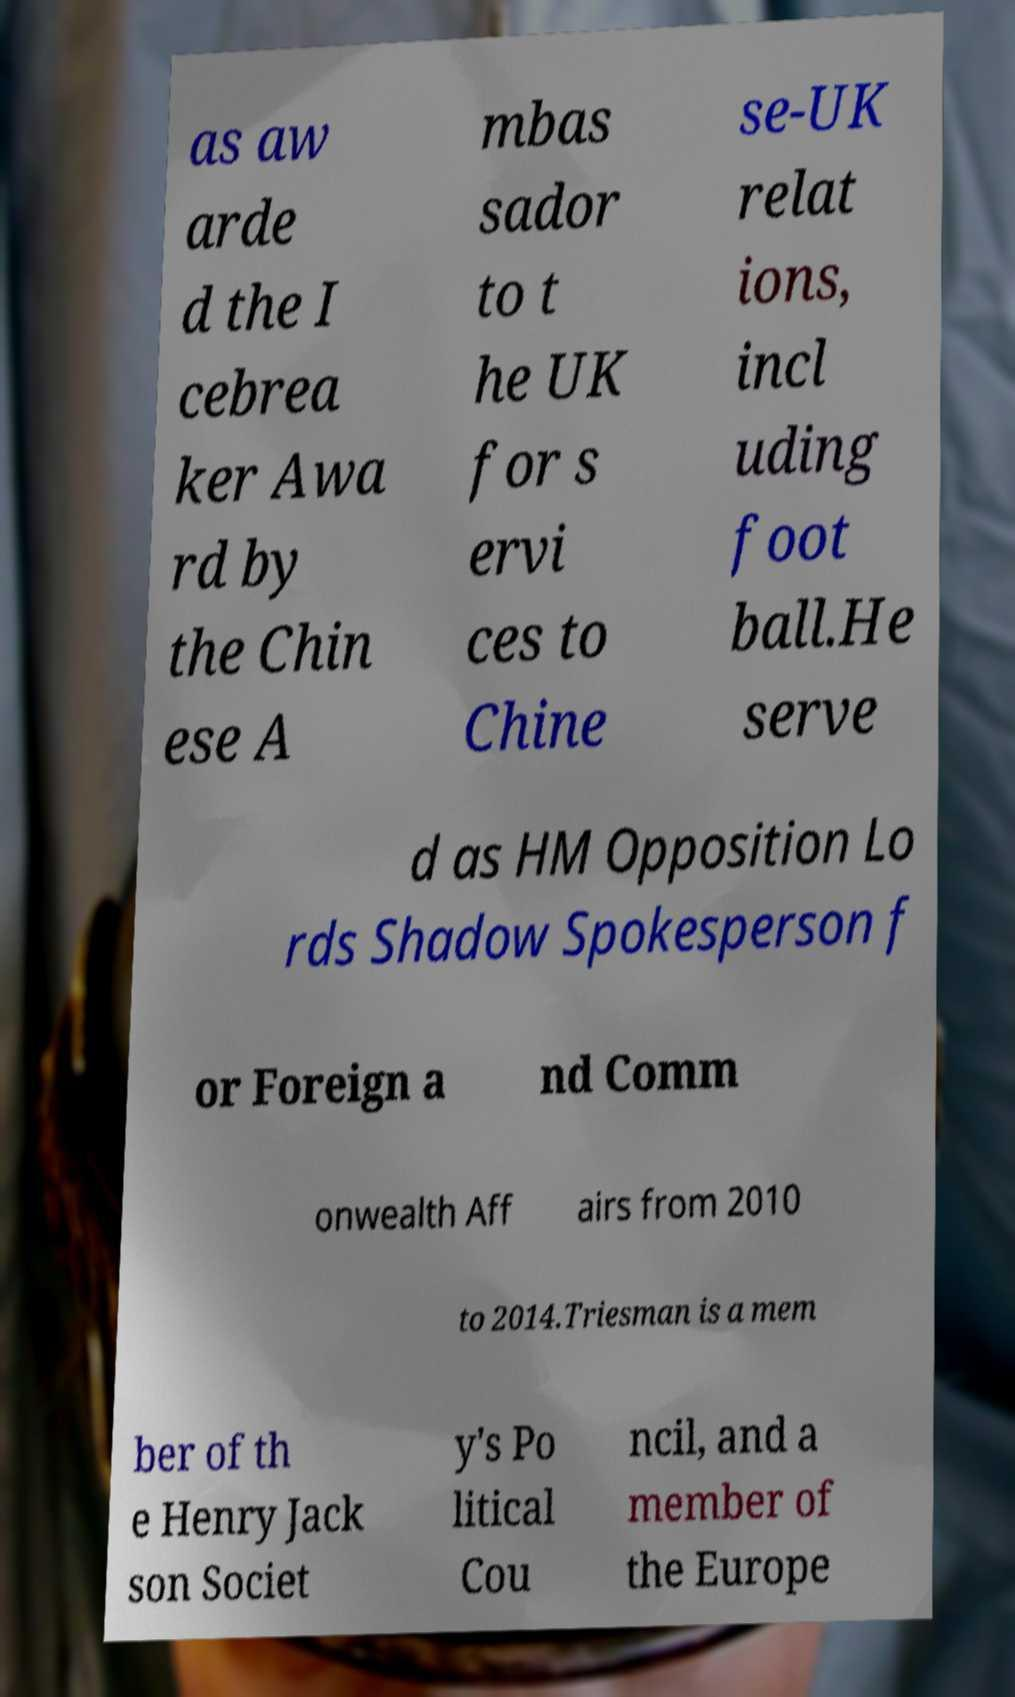Please identify and transcribe the text found in this image. as aw arde d the I cebrea ker Awa rd by the Chin ese A mbas sador to t he UK for s ervi ces to Chine se-UK relat ions, incl uding foot ball.He serve d as HM Opposition Lo rds Shadow Spokesperson f or Foreign a nd Comm onwealth Aff airs from 2010 to 2014.Triesman is a mem ber of th e Henry Jack son Societ y's Po litical Cou ncil, and a member of the Europe 